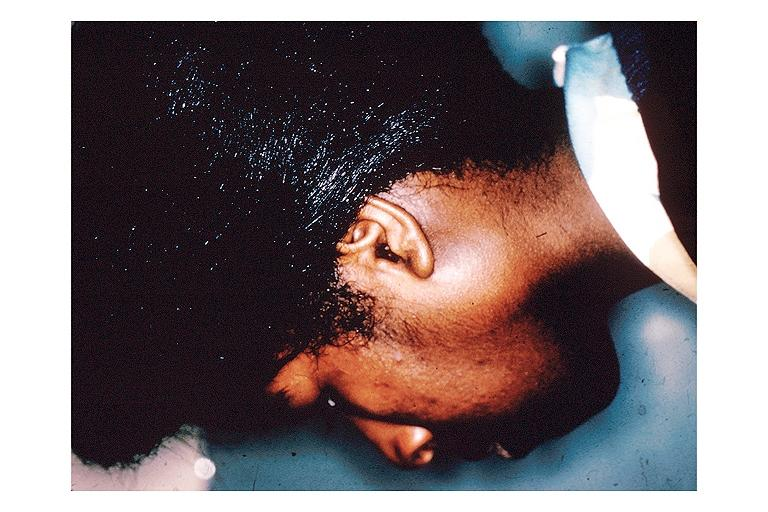what is present?
Answer the question using a single word or phrase. Oral 